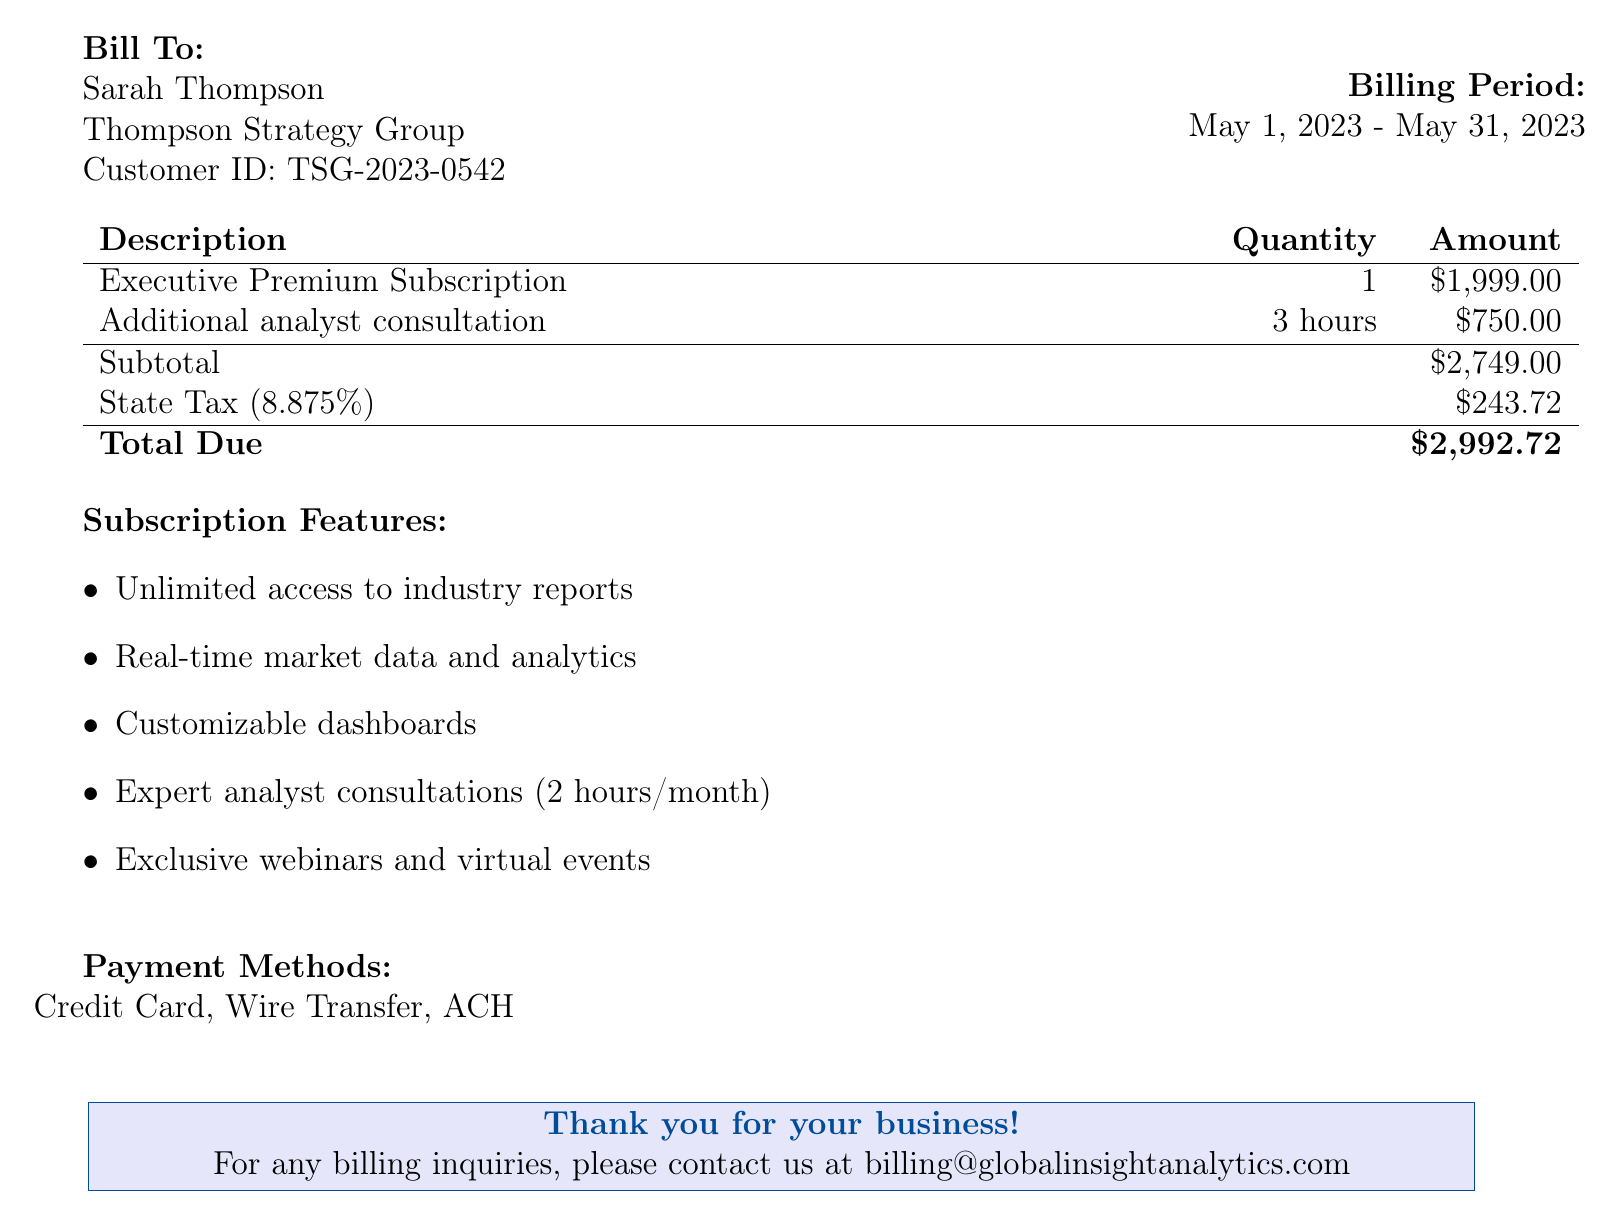What is the name of the company? The company's name is provided at the top of the invoice, identifying the service provider.
Answer: GlobalInsight Analytics Who is the bill addressed to? The recipient of the bill is specified in the "Bill To" section of the document.
Answer: Sarah Thompson What is the total due amount? The "Total Due" section outlines the complete amount payable as stated in the invoice.
Answer: $2,992.72 What is the billing period for this invoice? The billing period is clearly stated within the document, indicating the timeframe for the subscription.
Answer: May 1, 2023 - May 31, 2023 How many hours of additional analyst consultation were billed? The quantity of additional hours for analyst consultation is detailed in the itemized section of the invoice.
Answer: 3 hours What is the state tax percentage applied? The tax percentage is indicated next to the state tax amount, showing the rate used for calculations.
Answer: 8.875% What is the customer ID? The customer ID is specified in the "Bill To" section, providing unique identification for the billing record.
Answer: TSG-2023-0542 What is one feature included in the subscription? The subscription features are listed in the document, indicating services provided under the premium access.
Answer: Unlimited access to industry reports What payment methods are accepted? The document includes a section detailing acceptable payment options for the invoice.
Answer: Credit Card, Wire Transfer, ACH 